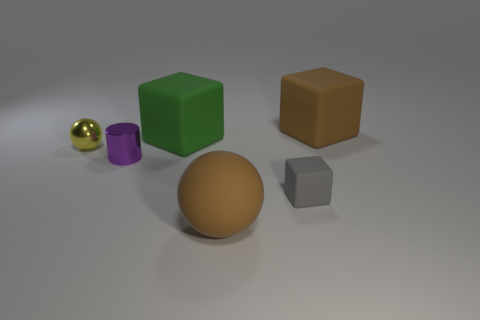Subtract all big blocks. How many blocks are left? 1 Add 4 large brown rubber objects. How many objects exist? 10 Subtract all green blocks. How many blocks are left? 2 Subtract all balls. How many objects are left? 4 Add 3 purple metallic things. How many purple metallic things exist? 4 Subtract 0 blue cylinders. How many objects are left? 6 Subtract all cyan cubes. Subtract all purple cylinders. How many cubes are left? 3 Subtract all brown matte objects. Subtract all tiny yellow cubes. How many objects are left? 4 Add 5 big rubber cubes. How many big rubber cubes are left? 7 